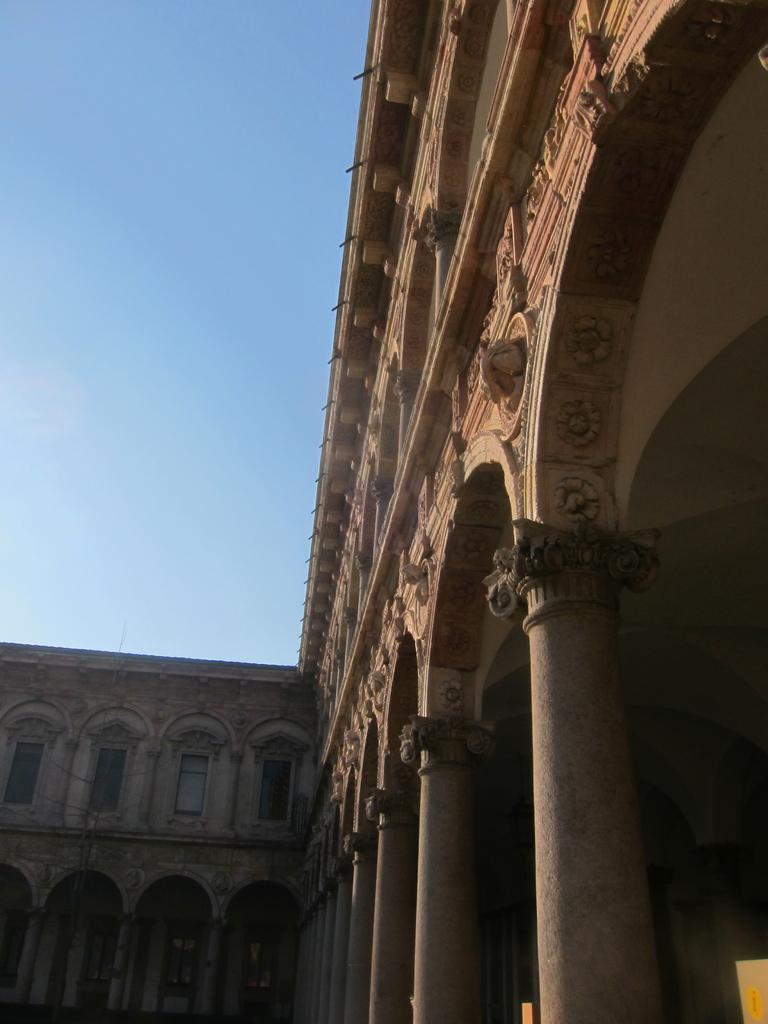What type of structure is present in the image? There is a building in the image. What architectural features can be seen on the building? The building has windows and pillars. What is the color of the sky in the image? The sky is blue in color. Can you tell me how many calculators are on the roof of the building in the image? There is no calculator present on the roof of the building in the image. What type of tooth is visible on the side of the building in the image? There is no tooth present on the side of the building in the image. 